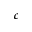Convert formula to latex. <formula><loc_0><loc_0><loc_500><loc_500>c</formula> 